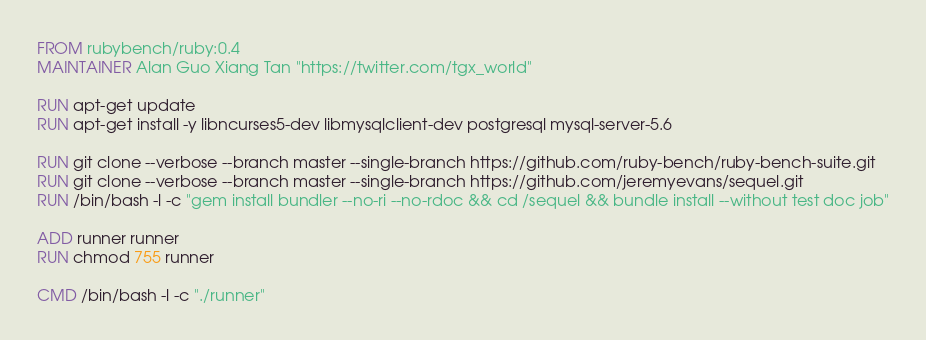Convert code to text. <code><loc_0><loc_0><loc_500><loc_500><_Dockerfile_>FROM rubybench/ruby:0.4
MAINTAINER Alan Guo Xiang Tan "https://twitter.com/tgx_world"

RUN apt-get update
RUN apt-get install -y libncurses5-dev libmysqlclient-dev postgresql mysql-server-5.6

RUN git clone --verbose --branch master --single-branch https://github.com/ruby-bench/ruby-bench-suite.git
RUN git clone --verbose --branch master --single-branch https://github.com/jeremyevans/sequel.git
RUN /bin/bash -l -c "gem install bundler --no-ri --no-rdoc && cd /sequel && bundle install --without test doc job"

ADD runner runner
RUN chmod 755 runner

CMD /bin/bash -l -c "./runner"
</code> 